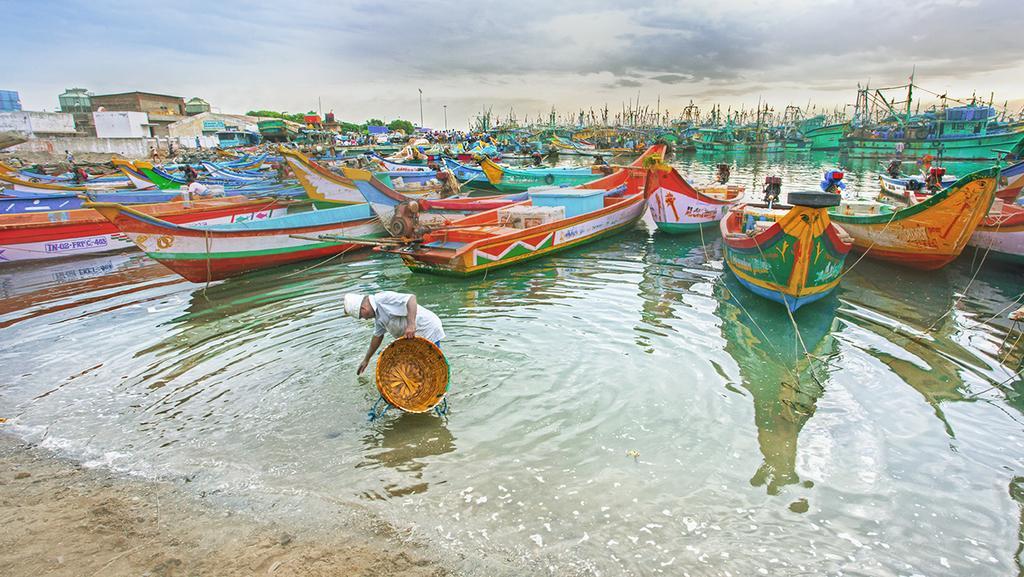Can you describe this image briefly? In this picture I can see there is a man standing in the water, he is holding a basket. There are few skiffs in the backdrop, they are sailing on the water, there are buildings at left side, there are trees and the sky is clear. 